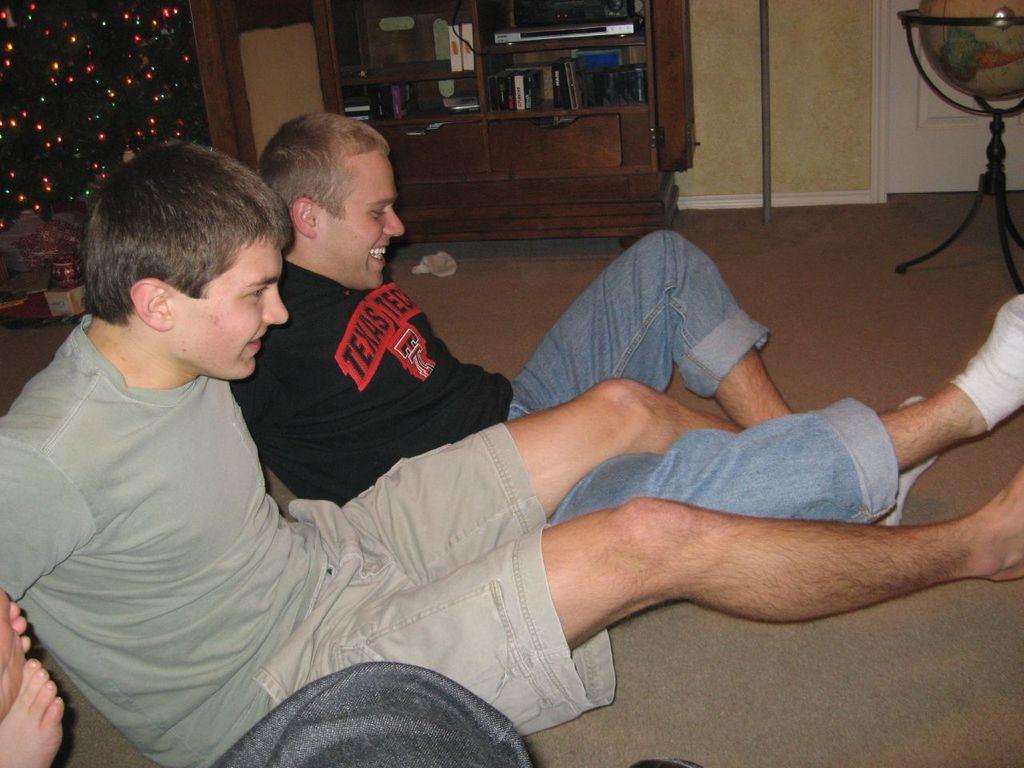What college is on the boys tee shirt?
Provide a short and direct response. Texas tech. What is the abbreviation for texas tech that is seen on this man's shirt?
Your response must be concise. Tt. 